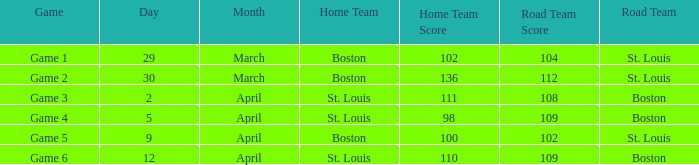What is the Game number on March 30? Game 2. 